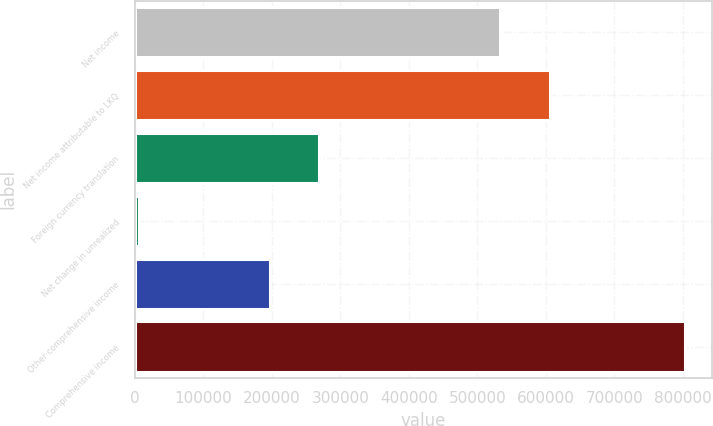<chart> <loc_0><loc_0><loc_500><loc_500><bar_chart><fcel>Net income<fcel>Net income attributable to LKQ<fcel>Foreign currency translation<fcel>Net change in unrealized<fcel>Other comprehensive income<fcel>Comprehensive income<nl><fcel>533744<fcel>606185<fcel>269140<fcel>6035<fcel>196699<fcel>802884<nl></chart> 